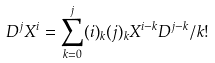<formula> <loc_0><loc_0><loc_500><loc_500>D ^ { j } X ^ { i } = \sum _ { k = 0 } ^ { j } ( i ) _ { k } ( j ) _ { k } X ^ { i - k } D ^ { j - k } / k !</formula> 